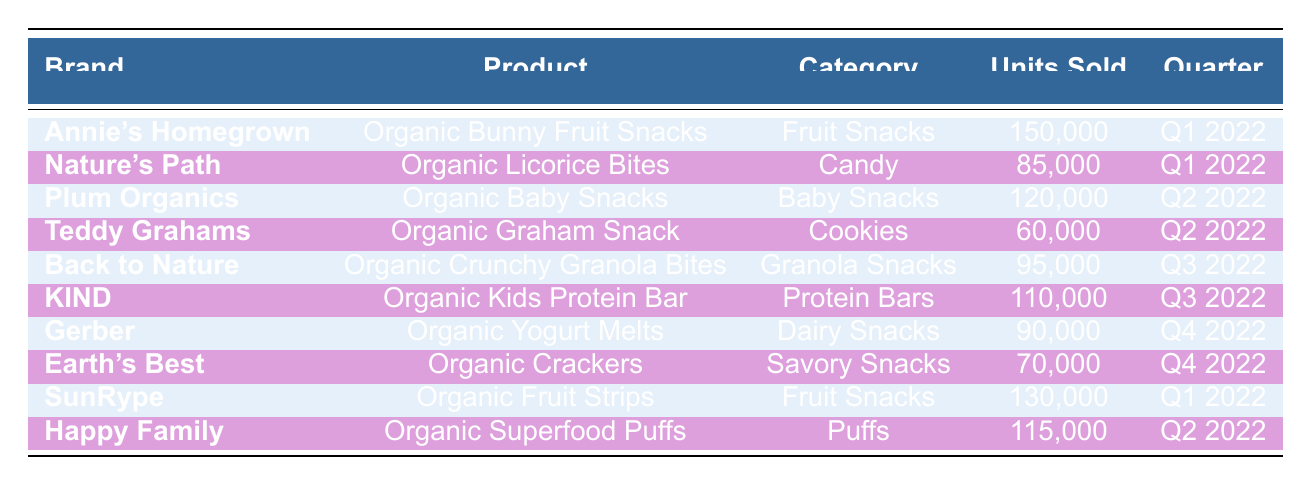What is the best-selling product in Q1 2022? In the table, there are two products listed for Q1 2022: "Organic Bunny Fruit Snacks" with 150,000 units sold, and "Organic Fruit Strips" with 130,000 units sold. Since "Organic Bunny Fruit Snacks" has the highest units sold, it is considered the best-selling product for that quarter.
Answer: Organic Bunny Fruit Snacks Which category had the highest sales in Q3 2022? In Q3 2022, there are two products: "Organic Crunchy Granola Bites" with 95,000 units sold and "Organic Kids Protein Bar" with 110,000 units sold. Comparing these two, the category with the highest sales is "Protein Bars" because it had 110,000 units sold.
Answer: Protein Bars What is the total number of units sold for all products in Q2 2022? In Q2 2022, the products are: "Organic Baby Snacks" with 120,000 units, "Organic Graham Snack" with 60,000 units, and "Organic Superfood Puffs" with 115,000 units. Adding these together gives: 120,000 + 60,000 + 115,000 = 295,000 units sold in total for Q2 2022.
Answer: 295,000 Did "Earth's Best" sell more units than "Gerber" in Q4 2022? In Q4 2022, "Earth's Best" sold 70,000 units and "Gerber" sold 90,000 units. Since 70,000 is less than 90,000, "Earth's Best" did not sell more units than "Gerber."
Answer: No What is the average number of units sold across all brands for the year 2022? To find the average, first, we sum the units sold across all products: 150,000 + 85,000 + 120,000 + 60,000 + 95,000 + 110,000 + 90,000 + 70,000 + 130,000 + 115,000 = 1,100,000. There are 10 products, so the average is 1,100,000 / 10 = 110,000 units sold.
Answer: 110,000 Which product had the lowest units sold in 2022? Looking at the data, "Organic Graham Snack" sold 60,000 units, which is less than any other product's sales. There are no other products with lower sales, confirming it as the lowest sold product.
Answer: Organic Graham Snack How many units were sold in total during the first half of 2022 (Q1 and Q2)? For Q1, units sold are: "Organic Bunny Fruit Snacks" (150,000) and "Organic Fruit Strips" (130,000). For Q2: "Organic Baby Snacks" (120,000), "Organic Graham Snack" (60,000), and "Organic Superfood Puffs" (115,000). Summing these together: 150,000 + 130,000 + 120,000 + 60,000 + 115,000 = 575,000 units sold in the first half of 2022.
Answer: 575,000 Which two brands had the highest units sold combined in Q1 2022? In Q1 2022, the products sold were "Organic Bunny Fruit Snacks" (150,000 units) and "Organic Fruit Strips" (130,000 units). Adding these together gives us 150,000 + 130,000 = 280,000 units combined. Thus, the two brands with the highest combined sales in Q1 2022 are these.
Answer: 280,000 Is the total number of units sold for all fruit snacks greater than that of savory snacks in 2022? Units sold for fruit snacks: "Organic Bunny Fruit Snacks" (150,000) + "Organic Fruit Strips" (130,000) = 280,000. For savory snacks, there is only "Organic Crackers" with 70,000 units. Comparing these totals, 280,000 is greater than 70,000, confirming that fruit snacks had higher sales.
Answer: Yes 